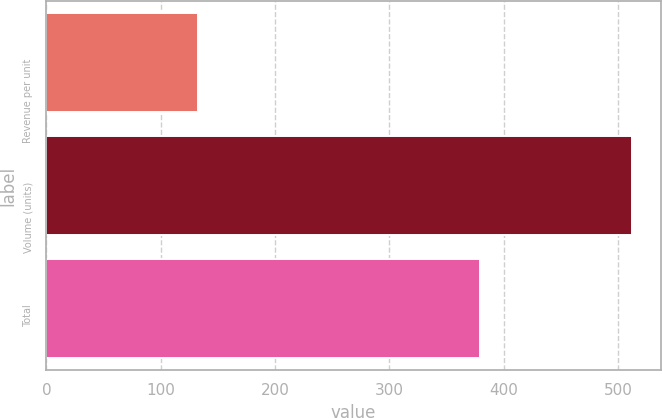Convert chart to OTSL. <chart><loc_0><loc_0><loc_500><loc_500><bar_chart><fcel>Revenue per unit<fcel>Volume (units)<fcel>Total<nl><fcel>133<fcel>512<fcel>379<nl></chart> 